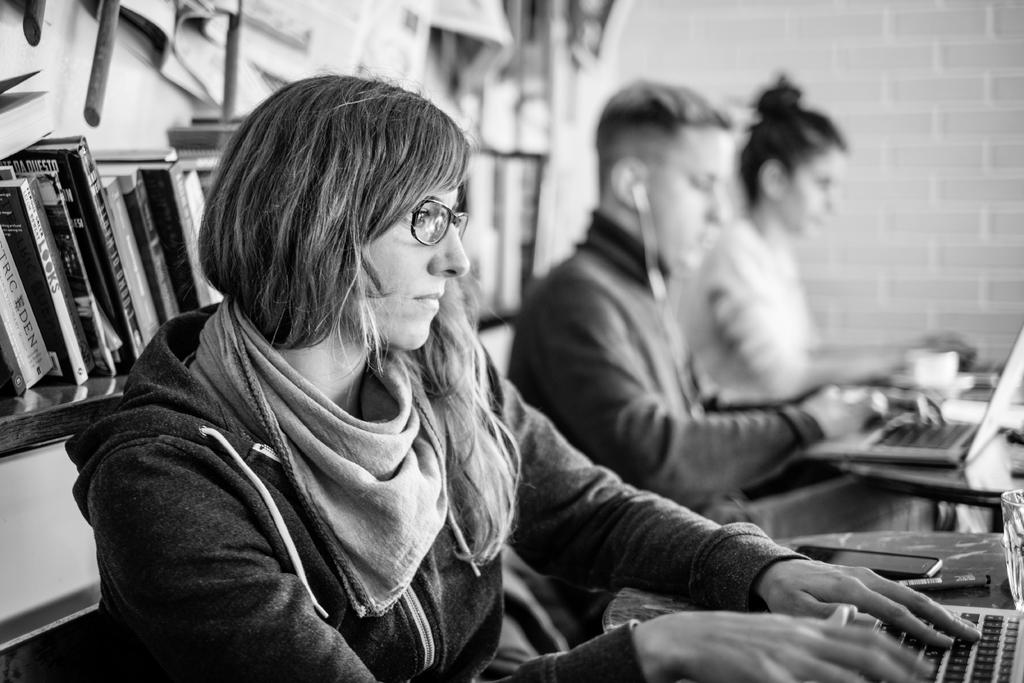<image>
Summarize the visual content of the image. Looks chapter book on a book shelf standing up. 